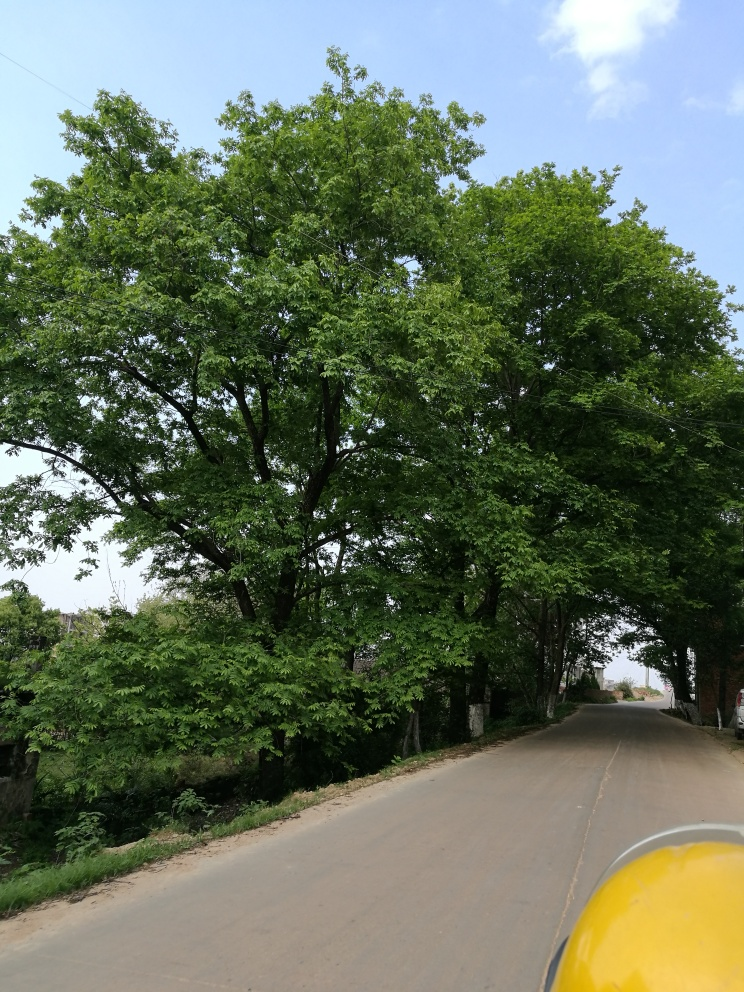Are there any quality issues with this image? The image is generally clear with good lighting and no significant blurring. The composition is straightforward, featuring a road with green trees on the sides under a cloudy sky. There don't appear to be any major quality issues that would impede viewing or interpreting the scene. However, the object in the lower right corner, possibly the edge of a vehicle, slightly intrudes into the frame which could be considered a minor compositional flaw. 